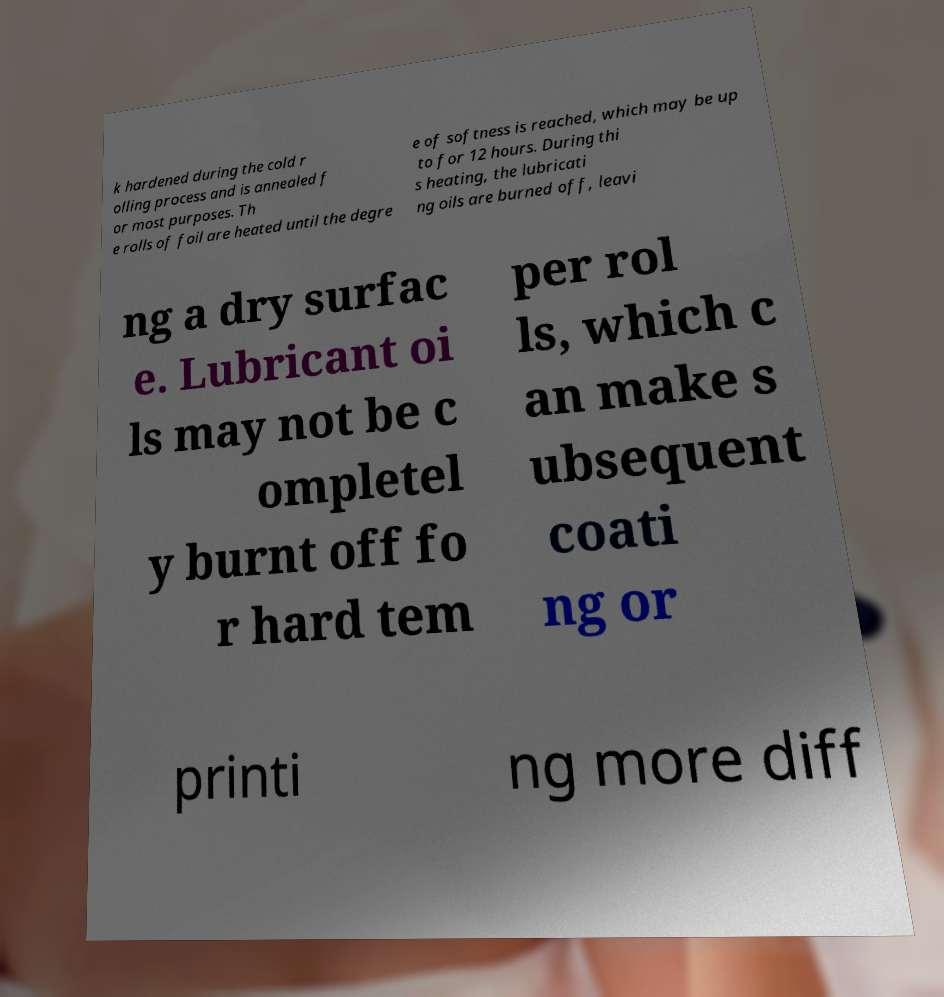Could you extract and type out the text from this image? k hardened during the cold r olling process and is annealed f or most purposes. Th e rolls of foil are heated until the degre e of softness is reached, which may be up to for 12 hours. During thi s heating, the lubricati ng oils are burned off, leavi ng a dry surfac e. Lubricant oi ls may not be c ompletel y burnt off fo r hard tem per rol ls, which c an make s ubsequent coati ng or printi ng more diff 